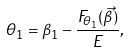<formula> <loc_0><loc_0><loc_500><loc_500>\theta _ { 1 } = \beta _ { 1 } - \frac { F _ { \theta _ { 1 } } ( \vec { \beta } ) } { E } ,</formula> 